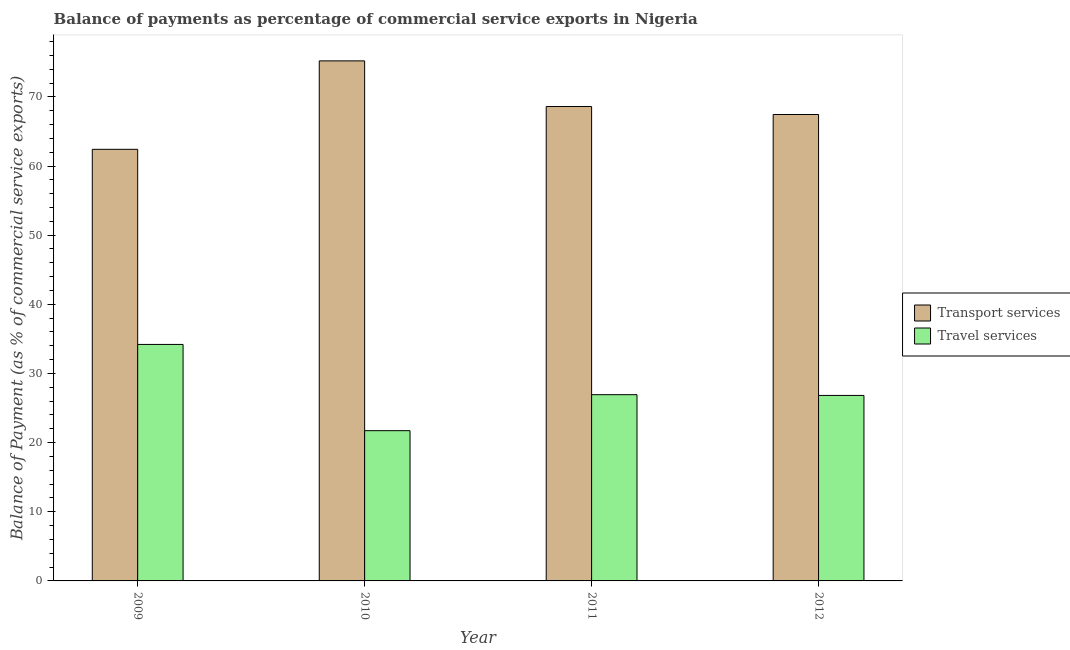How many different coloured bars are there?
Provide a succinct answer. 2. Are the number of bars per tick equal to the number of legend labels?
Offer a terse response. Yes. What is the label of the 1st group of bars from the left?
Give a very brief answer. 2009. What is the balance of payments of transport services in 2009?
Your answer should be very brief. 62.41. Across all years, what is the maximum balance of payments of transport services?
Your answer should be compact. 75.2. Across all years, what is the minimum balance of payments of transport services?
Your response must be concise. 62.41. What is the total balance of payments of travel services in the graph?
Ensure brevity in your answer.  109.68. What is the difference between the balance of payments of travel services in 2010 and that in 2012?
Provide a short and direct response. -5.1. What is the difference between the balance of payments of transport services in 2010 and the balance of payments of travel services in 2009?
Give a very brief answer. 12.79. What is the average balance of payments of transport services per year?
Provide a short and direct response. 68.42. In the year 2010, what is the difference between the balance of payments of travel services and balance of payments of transport services?
Your answer should be compact. 0. What is the ratio of the balance of payments of travel services in 2009 to that in 2011?
Provide a succinct answer. 1.27. Is the difference between the balance of payments of travel services in 2009 and 2011 greater than the difference between the balance of payments of transport services in 2009 and 2011?
Make the answer very short. No. What is the difference between the highest and the second highest balance of payments of transport services?
Offer a very short reply. 6.6. What is the difference between the highest and the lowest balance of payments of travel services?
Your answer should be very brief. 12.47. What does the 1st bar from the left in 2010 represents?
Offer a very short reply. Transport services. What does the 1st bar from the right in 2011 represents?
Provide a short and direct response. Travel services. What is the title of the graph?
Your response must be concise. Balance of payments as percentage of commercial service exports in Nigeria. What is the label or title of the Y-axis?
Give a very brief answer. Balance of Payment (as % of commercial service exports). What is the Balance of Payment (as % of commercial service exports) of Transport services in 2009?
Your response must be concise. 62.41. What is the Balance of Payment (as % of commercial service exports) of Travel services in 2009?
Your response must be concise. 34.2. What is the Balance of Payment (as % of commercial service exports) of Transport services in 2010?
Offer a terse response. 75.2. What is the Balance of Payment (as % of commercial service exports) in Travel services in 2010?
Your answer should be very brief. 21.73. What is the Balance of Payment (as % of commercial service exports) in Transport services in 2011?
Your answer should be compact. 68.6. What is the Balance of Payment (as % of commercial service exports) of Travel services in 2011?
Give a very brief answer. 26.93. What is the Balance of Payment (as % of commercial service exports) in Transport services in 2012?
Offer a terse response. 67.45. What is the Balance of Payment (as % of commercial service exports) in Travel services in 2012?
Your answer should be very brief. 26.82. Across all years, what is the maximum Balance of Payment (as % of commercial service exports) of Transport services?
Keep it short and to the point. 75.2. Across all years, what is the maximum Balance of Payment (as % of commercial service exports) of Travel services?
Offer a terse response. 34.2. Across all years, what is the minimum Balance of Payment (as % of commercial service exports) of Transport services?
Offer a terse response. 62.41. Across all years, what is the minimum Balance of Payment (as % of commercial service exports) of Travel services?
Offer a terse response. 21.73. What is the total Balance of Payment (as % of commercial service exports) in Transport services in the graph?
Keep it short and to the point. 273.66. What is the total Balance of Payment (as % of commercial service exports) of Travel services in the graph?
Offer a terse response. 109.68. What is the difference between the Balance of Payment (as % of commercial service exports) of Transport services in 2009 and that in 2010?
Make the answer very short. -12.79. What is the difference between the Balance of Payment (as % of commercial service exports) in Travel services in 2009 and that in 2010?
Provide a short and direct response. 12.47. What is the difference between the Balance of Payment (as % of commercial service exports) of Transport services in 2009 and that in 2011?
Provide a succinct answer. -6.19. What is the difference between the Balance of Payment (as % of commercial service exports) of Travel services in 2009 and that in 2011?
Your answer should be compact. 7.27. What is the difference between the Balance of Payment (as % of commercial service exports) of Transport services in 2009 and that in 2012?
Provide a succinct answer. -5.04. What is the difference between the Balance of Payment (as % of commercial service exports) of Travel services in 2009 and that in 2012?
Your answer should be very brief. 7.37. What is the difference between the Balance of Payment (as % of commercial service exports) of Transport services in 2010 and that in 2011?
Offer a terse response. 6.6. What is the difference between the Balance of Payment (as % of commercial service exports) in Travel services in 2010 and that in 2011?
Keep it short and to the point. -5.21. What is the difference between the Balance of Payment (as % of commercial service exports) in Transport services in 2010 and that in 2012?
Give a very brief answer. 7.75. What is the difference between the Balance of Payment (as % of commercial service exports) of Travel services in 2010 and that in 2012?
Provide a succinct answer. -5.1. What is the difference between the Balance of Payment (as % of commercial service exports) in Transport services in 2011 and that in 2012?
Your answer should be very brief. 1.15. What is the difference between the Balance of Payment (as % of commercial service exports) of Travel services in 2011 and that in 2012?
Provide a succinct answer. 0.11. What is the difference between the Balance of Payment (as % of commercial service exports) of Transport services in 2009 and the Balance of Payment (as % of commercial service exports) of Travel services in 2010?
Make the answer very short. 40.69. What is the difference between the Balance of Payment (as % of commercial service exports) of Transport services in 2009 and the Balance of Payment (as % of commercial service exports) of Travel services in 2011?
Your answer should be very brief. 35.48. What is the difference between the Balance of Payment (as % of commercial service exports) in Transport services in 2009 and the Balance of Payment (as % of commercial service exports) in Travel services in 2012?
Offer a very short reply. 35.59. What is the difference between the Balance of Payment (as % of commercial service exports) in Transport services in 2010 and the Balance of Payment (as % of commercial service exports) in Travel services in 2011?
Provide a short and direct response. 48.27. What is the difference between the Balance of Payment (as % of commercial service exports) in Transport services in 2010 and the Balance of Payment (as % of commercial service exports) in Travel services in 2012?
Provide a succinct answer. 48.38. What is the difference between the Balance of Payment (as % of commercial service exports) of Transport services in 2011 and the Balance of Payment (as % of commercial service exports) of Travel services in 2012?
Give a very brief answer. 41.78. What is the average Balance of Payment (as % of commercial service exports) in Transport services per year?
Your answer should be very brief. 68.42. What is the average Balance of Payment (as % of commercial service exports) of Travel services per year?
Make the answer very short. 27.42. In the year 2009, what is the difference between the Balance of Payment (as % of commercial service exports) in Transport services and Balance of Payment (as % of commercial service exports) in Travel services?
Your response must be concise. 28.21. In the year 2010, what is the difference between the Balance of Payment (as % of commercial service exports) in Transport services and Balance of Payment (as % of commercial service exports) in Travel services?
Your answer should be very brief. 53.48. In the year 2011, what is the difference between the Balance of Payment (as % of commercial service exports) in Transport services and Balance of Payment (as % of commercial service exports) in Travel services?
Provide a succinct answer. 41.67. In the year 2012, what is the difference between the Balance of Payment (as % of commercial service exports) in Transport services and Balance of Payment (as % of commercial service exports) in Travel services?
Provide a succinct answer. 40.62. What is the ratio of the Balance of Payment (as % of commercial service exports) in Transport services in 2009 to that in 2010?
Provide a short and direct response. 0.83. What is the ratio of the Balance of Payment (as % of commercial service exports) in Travel services in 2009 to that in 2010?
Offer a very short reply. 1.57. What is the ratio of the Balance of Payment (as % of commercial service exports) of Transport services in 2009 to that in 2011?
Provide a succinct answer. 0.91. What is the ratio of the Balance of Payment (as % of commercial service exports) in Travel services in 2009 to that in 2011?
Offer a terse response. 1.27. What is the ratio of the Balance of Payment (as % of commercial service exports) of Transport services in 2009 to that in 2012?
Offer a terse response. 0.93. What is the ratio of the Balance of Payment (as % of commercial service exports) of Travel services in 2009 to that in 2012?
Keep it short and to the point. 1.27. What is the ratio of the Balance of Payment (as % of commercial service exports) in Transport services in 2010 to that in 2011?
Provide a short and direct response. 1.1. What is the ratio of the Balance of Payment (as % of commercial service exports) in Travel services in 2010 to that in 2011?
Provide a succinct answer. 0.81. What is the ratio of the Balance of Payment (as % of commercial service exports) of Transport services in 2010 to that in 2012?
Provide a short and direct response. 1.11. What is the ratio of the Balance of Payment (as % of commercial service exports) of Travel services in 2010 to that in 2012?
Your response must be concise. 0.81. What is the ratio of the Balance of Payment (as % of commercial service exports) in Transport services in 2011 to that in 2012?
Keep it short and to the point. 1.02. What is the difference between the highest and the second highest Balance of Payment (as % of commercial service exports) of Transport services?
Ensure brevity in your answer.  6.6. What is the difference between the highest and the second highest Balance of Payment (as % of commercial service exports) of Travel services?
Provide a succinct answer. 7.27. What is the difference between the highest and the lowest Balance of Payment (as % of commercial service exports) in Transport services?
Ensure brevity in your answer.  12.79. What is the difference between the highest and the lowest Balance of Payment (as % of commercial service exports) of Travel services?
Your answer should be compact. 12.47. 